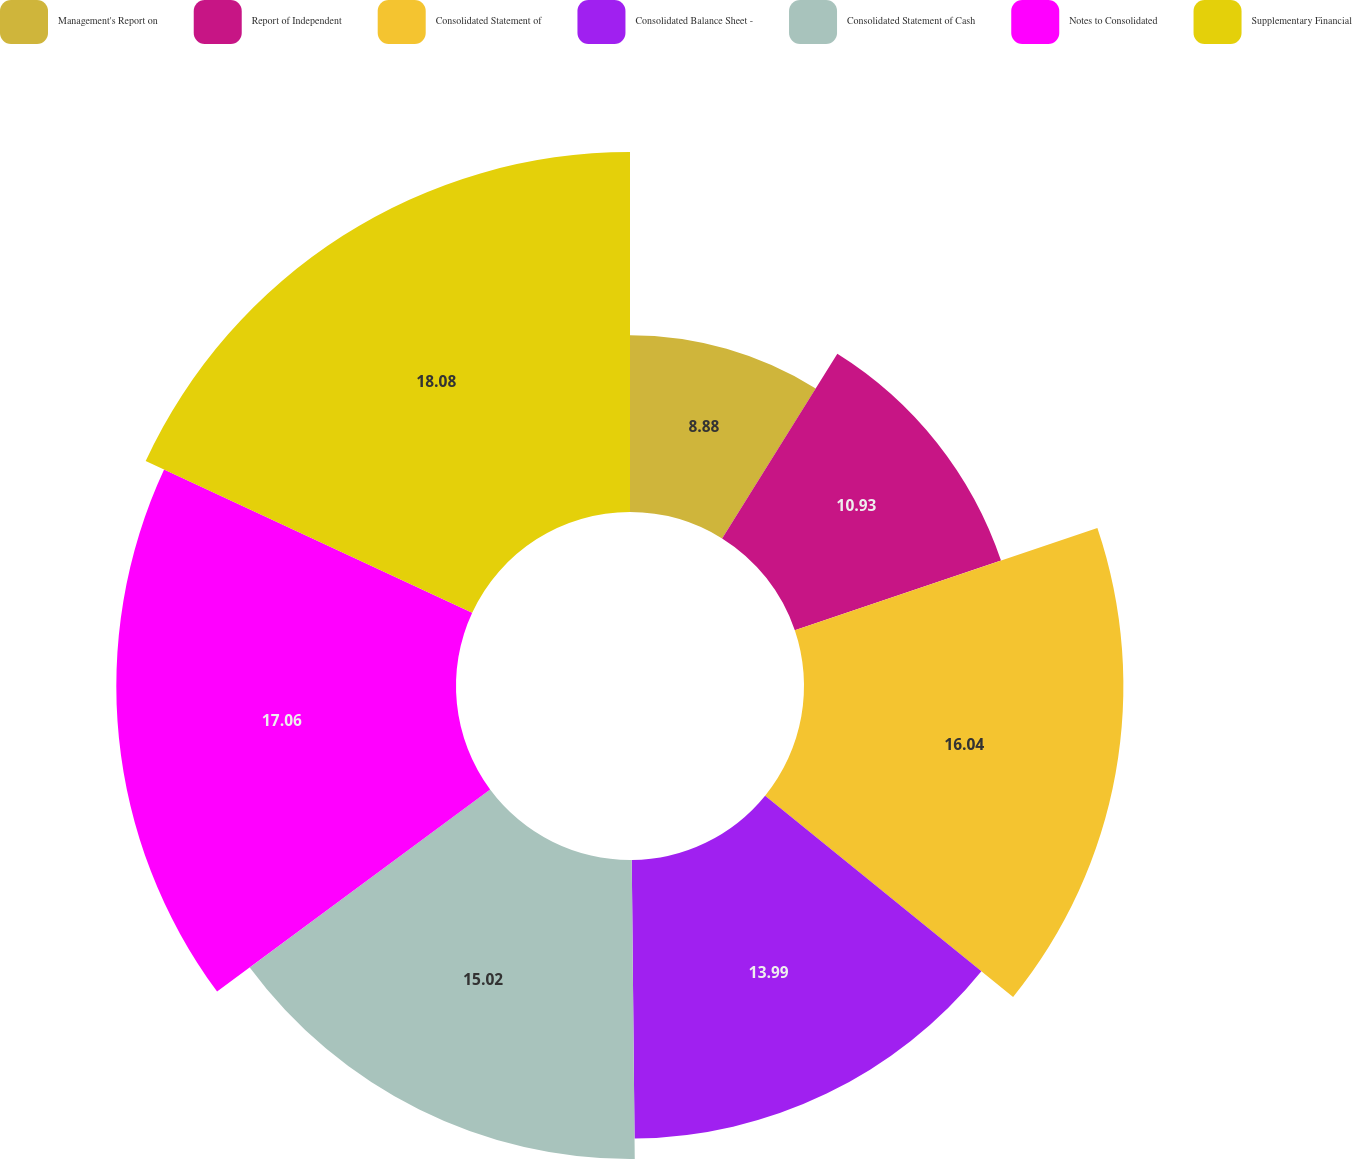Convert chart to OTSL. <chart><loc_0><loc_0><loc_500><loc_500><pie_chart><fcel>Management's Report on<fcel>Report of Independent<fcel>Consolidated Statement of<fcel>Consolidated Balance Sheet -<fcel>Consolidated Statement of Cash<fcel>Notes to Consolidated<fcel>Supplementary Financial<nl><fcel>8.88%<fcel>10.93%<fcel>16.04%<fcel>13.99%<fcel>15.02%<fcel>17.06%<fcel>18.08%<nl></chart> 